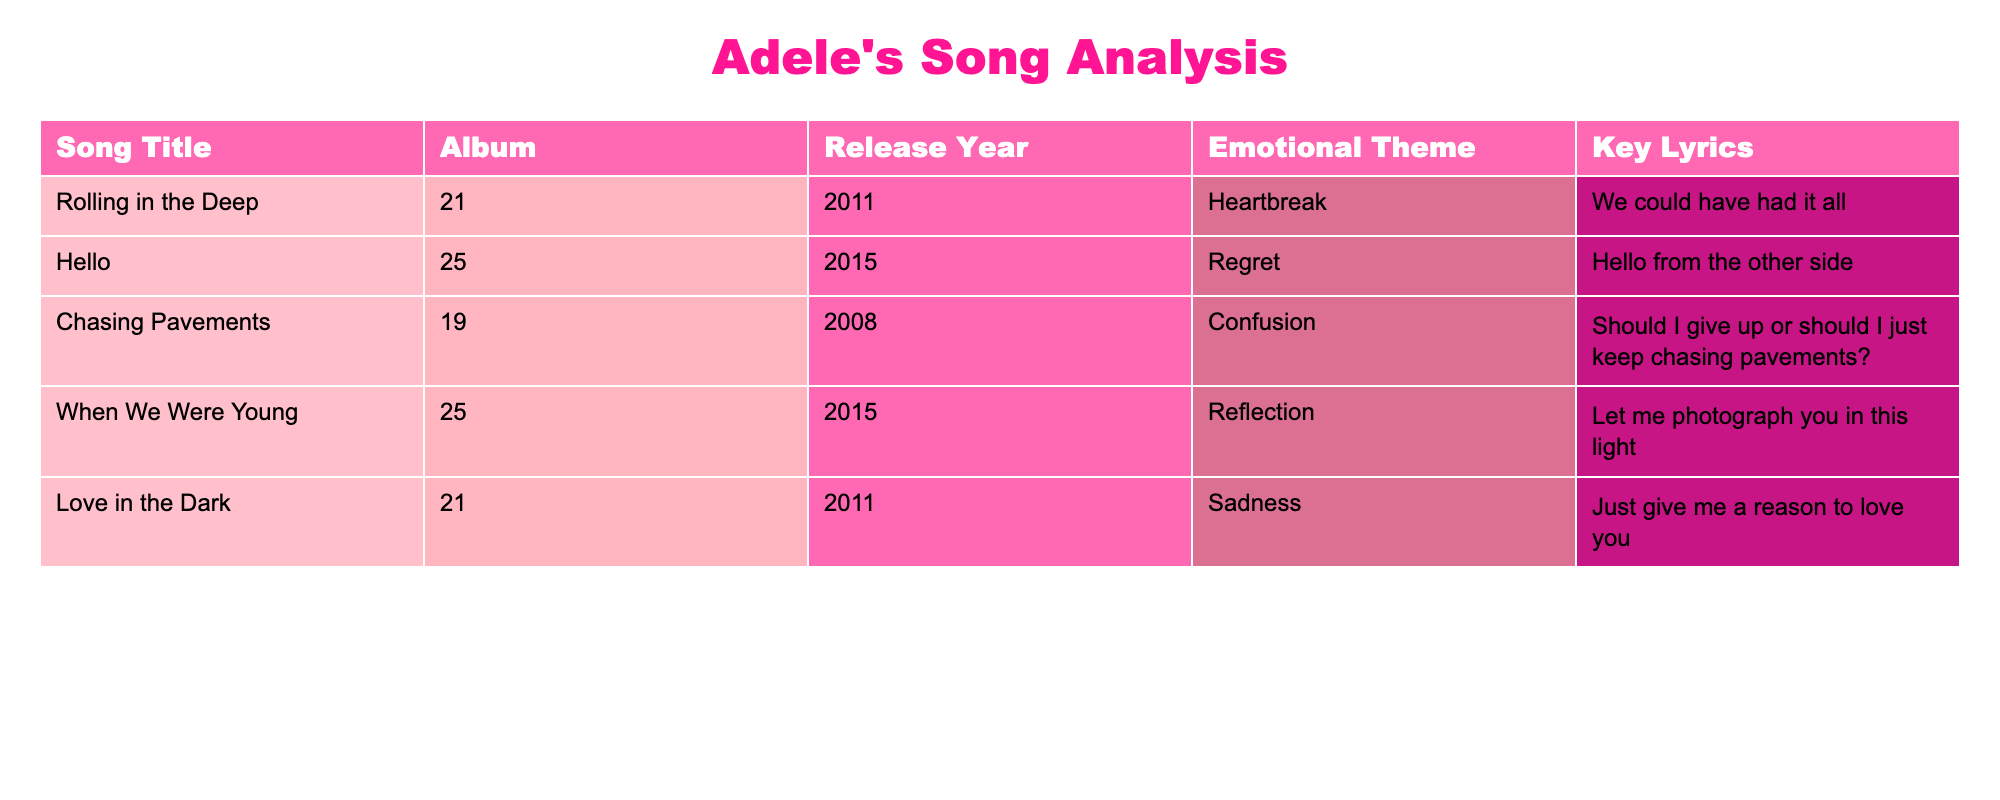What is the release year of "Chasing Pavements"? The table lists "Chasing Pavements" under the 'Release Year' column. This row shows that the release year is 2008.
Answer: 2008 Which song from the album "25" is associated with regret? The table shows two songs from the album "25": "Hello" and "When We Were Young." Looking at their emotional themes, "Hello" is associated with regret.
Answer: Hello How many songs have an emotional theme related to sadness? The table lists five songs, and we can check each of their emotional themes. Only one song, "Love in the Dark," is associated with sadness. Thus, the count is one.
Answer: 1 Is "Rolling in the Deep" related to confusion? By reviewing the emotional theme for "Rolling in the Deep," which is listed as heartbreak, we find that it is not associated with confusion, as that theme is for "Chasing Pavements."
Answer: No What is the emotional theme of the song "When We Were Young"? Looking at the row for "When We Were Young" in the emotional theme column, we see it is associated with reflection.
Answer: Reflection How many songs were released after 2013? The table shows the release years of all songs: 2011, 2015, 2008, 2015, and 2011. By counting, both "Hello" and "When We Were Young," which were released in 2015, are after 2013. Therefore, there are two songs.
Answer: 2 What is the emotional theme of the song with the key lyric "Should I give up or should I just keep chasing pavements?" This lyric belongs to "Chasing Pavements," which is listed to have the emotional theme of confusion in the table.
Answer: Confusion Are there multiple songs from the album "21"? The table shows two songs associated with the album "21": "Rolling in the Deep" and "Love in the Dark." Therefore, the answer to whether there are multiple songs is yes.
Answer: Yes What are the key lyrics from the song that corresponds to regret? The song "Hello" is associated with the emotional theme of regret. The key lyric identified in the table is "Hello from the other side."
Answer: Hello from the other side 